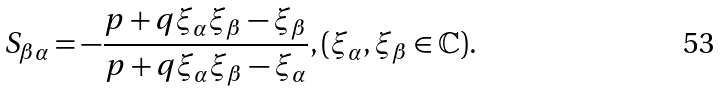Convert formula to latex. <formula><loc_0><loc_0><loc_500><loc_500>S _ { \beta \alpha } = - \frac { p + q \xi _ { \alpha } \xi _ { \beta } - \xi _ { \beta } } { p + q \xi _ { \alpha } \xi _ { \beta } - \xi _ { \alpha } } , ( \xi _ { \alpha } , \xi _ { \beta } \in \mathbb { C } ) .</formula> 